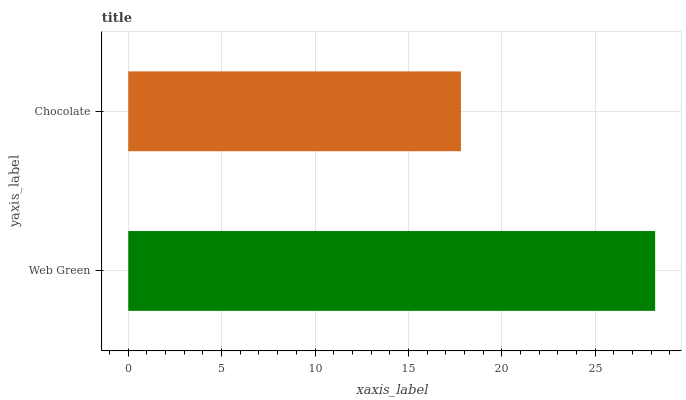Is Chocolate the minimum?
Answer yes or no. Yes. Is Web Green the maximum?
Answer yes or no. Yes. Is Chocolate the maximum?
Answer yes or no. No. Is Web Green greater than Chocolate?
Answer yes or no. Yes. Is Chocolate less than Web Green?
Answer yes or no. Yes. Is Chocolate greater than Web Green?
Answer yes or no. No. Is Web Green less than Chocolate?
Answer yes or no. No. Is Web Green the high median?
Answer yes or no. Yes. Is Chocolate the low median?
Answer yes or no. Yes. Is Chocolate the high median?
Answer yes or no. No. Is Web Green the low median?
Answer yes or no. No. 